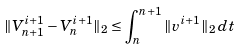Convert formula to latex. <formula><loc_0><loc_0><loc_500><loc_500>\| V _ { n + 1 } ^ { i + 1 } - V _ { n } ^ { i + 1 } \| _ { 2 } \leq \int _ { n } ^ { n + 1 } \| v ^ { i + 1 } \| _ { 2 } \, d t</formula> 